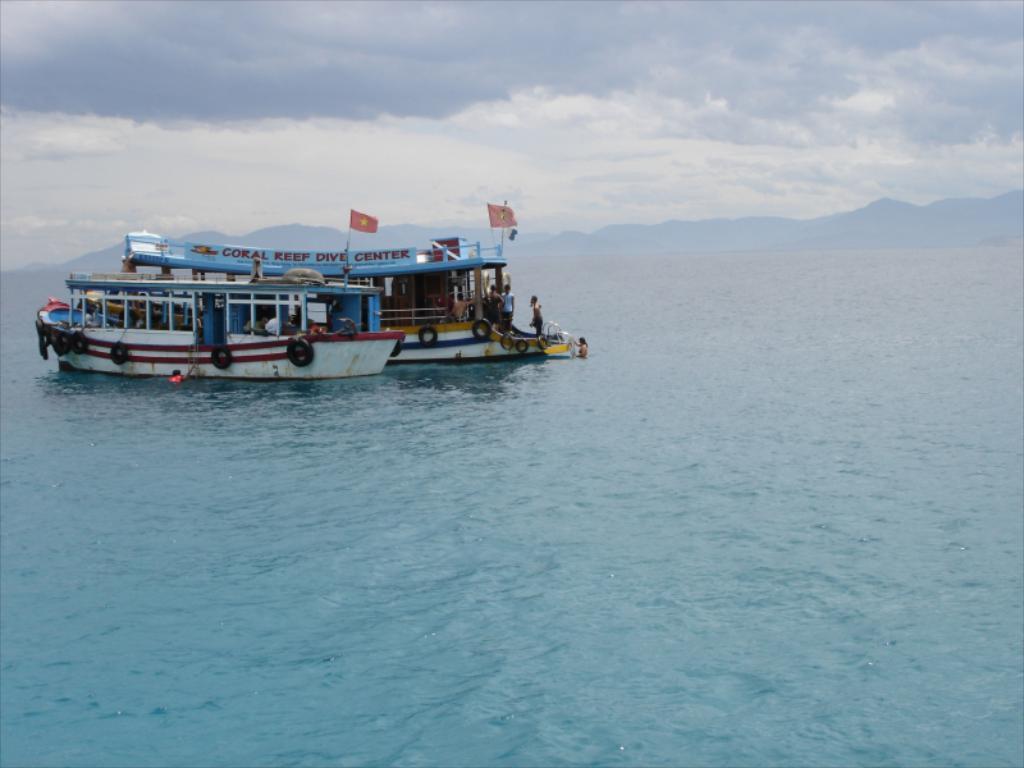Please provide a concise description of this image. There are boats on the water. On the boats there are flags, something is written, poles and tires. In the background there are hills and sky with clouds. Also there are few people in the boats. 